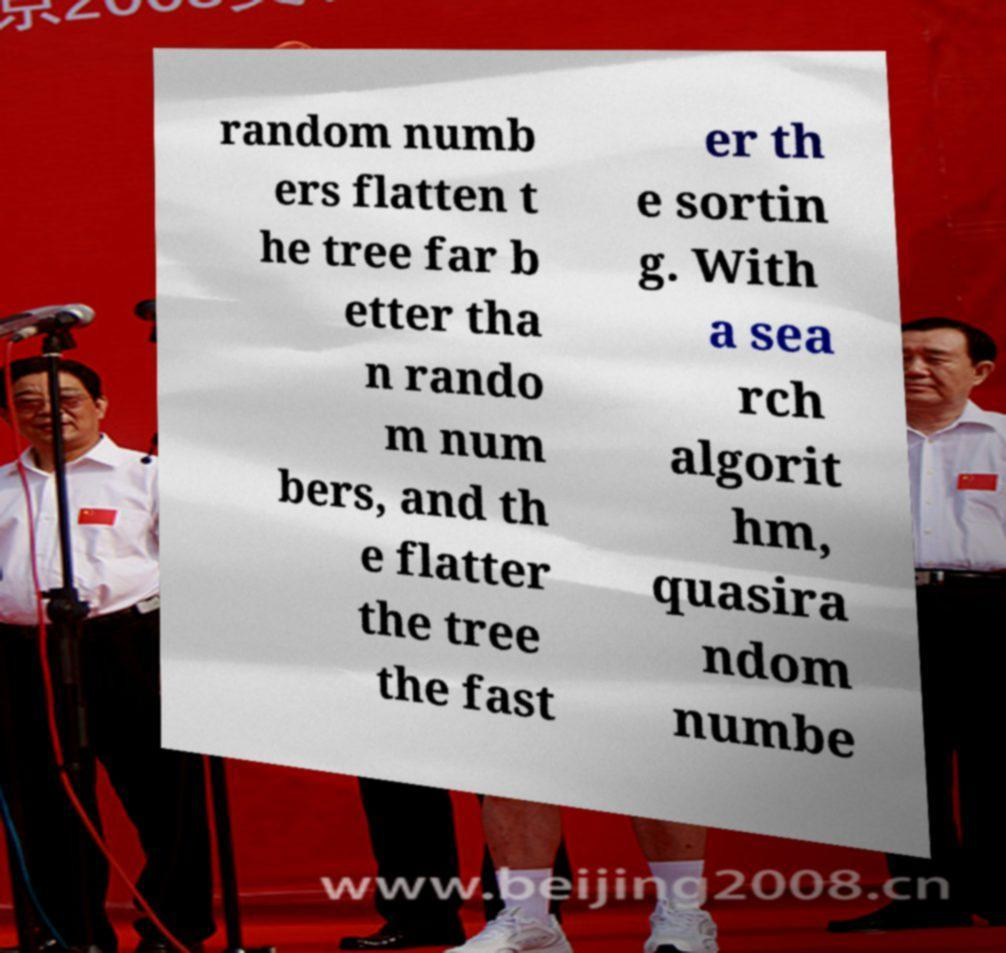For documentation purposes, I need the text within this image transcribed. Could you provide that? random numb ers flatten t he tree far b etter tha n rando m num bers, and th e flatter the tree the fast er th e sortin g. With a sea rch algorit hm, quasira ndom numbe 